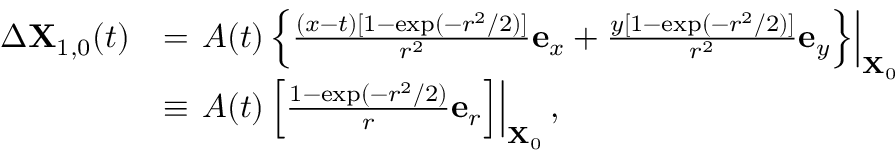Convert formula to latex. <formula><loc_0><loc_0><loc_500><loc_500>\begin{array} { r l } { \Delta X _ { 1 , 0 } ( t ) } & { = A ( t ) \left \{ \frac { ( x - t ) [ 1 - \exp ( - r ^ { 2 } / 2 ) ] } { r ^ { 2 } } e _ { x } + \frac { y [ 1 - \exp ( - r ^ { 2 } / 2 ) ] } { r ^ { 2 } } e _ { y } \right \} \right | _ { X _ { 0 } } } \\ & { \equiv A ( t ) \left [ \frac { 1 - \exp ( - r ^ { 2 } / 2 ) } { r } e _ { r } \right ] \right | _ { X _ { 0 } } , } \end{array}</formula> 